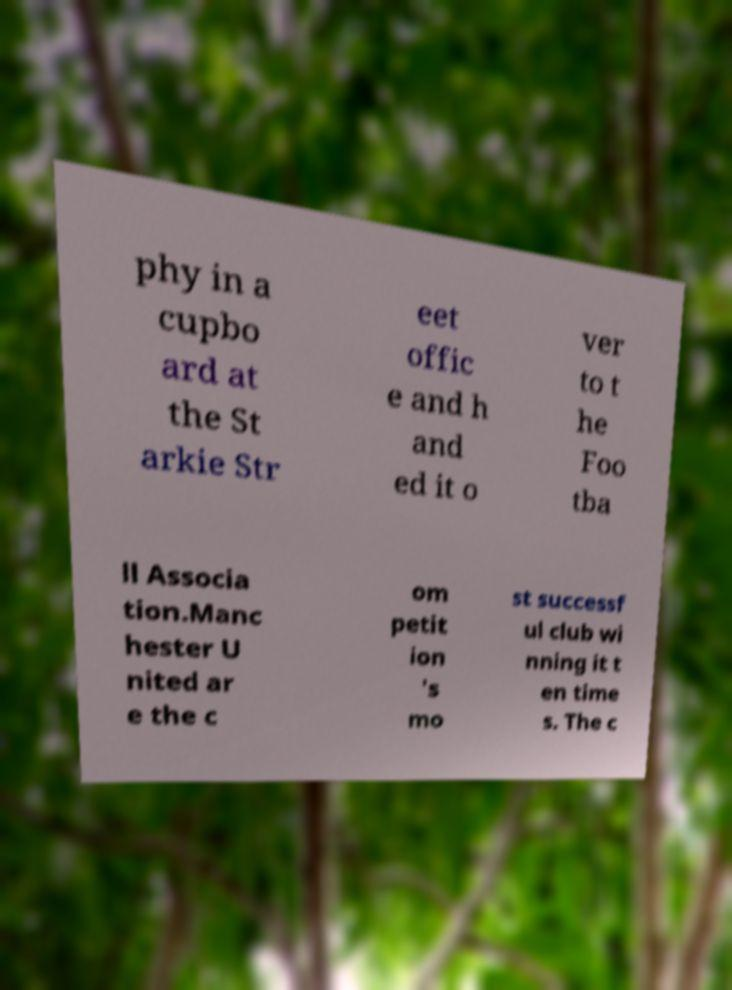I need the written content from this picture converted into text. Can you do that? phy in a cupbo ard at the St arkie Str eet offic e and h and ed it o ver to t he Foo tba ll Associa tion.Manc hester U nited ar e the c om petit ion 's mo st successf ul club wi nning it t en time s. The c 